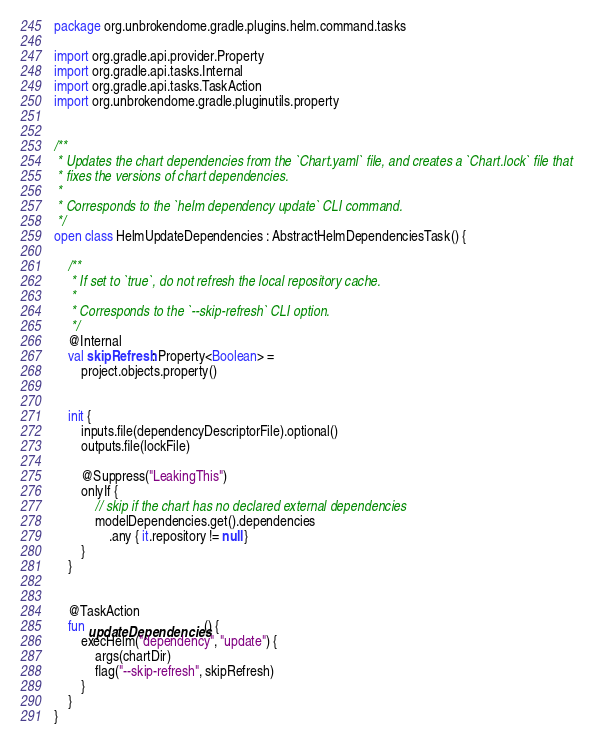Convert code to text. <code><loc_0><loc_0><loc_500><loc_500><_Kotlin_>package org.unbrokendome.gradle.plugins.helm.command.tasks

import org.gradle.api.provider.Property
import org.gradle.api.tasks.Internal
import org.gradle.api.tasks.TaskAction
import org.unbrokendome.gradle.pluginutils.property


/**
 * Updates the chart dependencies from the `Chart.yaml` file, and creates a `Chart.lock` file that
 * fixes the versions of chart dependencies.
 *
 * Corresponds to the `helm dependency update` CLI command.
 */
open class HelmUpdateDependencies : AbstractHelmDependenciesTask() {

    /**
     * If set to `true`, do not refresh the local repository cache.
     *
     * Corresponds to the `--skip-refresh` CLI option.
     */
    @Internal
    val skipRefresh: Property<Boolean> =
        project.objects.property()


    init {
        inputs.file(dependencyDescriptorFile).optional()
        outputs.file(lockFile)

        @Suppress("LeakingThis")
        onlyIf {
            // skip if the chart has no declared external dependencies
            modelDependencies.get().dependencies
                .any { it.repository != null }
        }
    }


    @TaskAction
    fun updateDependencies() {
        execHelm("dependency", "update") {
            args(chartDir)
            flag("--skip-refresh", skipRefresh)
        }
    }
}
</code> 